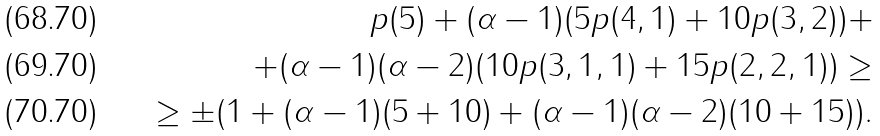Convert formula to latex. <formula><loc_0><loc_0><loc_500><loc_500>p ( 5 ) + ( \alpha - 1 ) ( 5 p ( 4 , 1 ) + 1 0 p ( 3 , 2 ) ) + \\ + ( \alpha - 1 ) ( \alpha - 2 ) ( 1 0 p ( 3 , 1 , 1 ) + 1 5 p ( 2 , 2 , 1 ) ) \geq \\ \geq \pm ( 1 + ( \alpha - 1 ) ( 5 + 1 0 ) + ( \alpha - 1 ) ( \alpha - 2 ) ( 1 0 + 1 5 ) ) .</formula> 